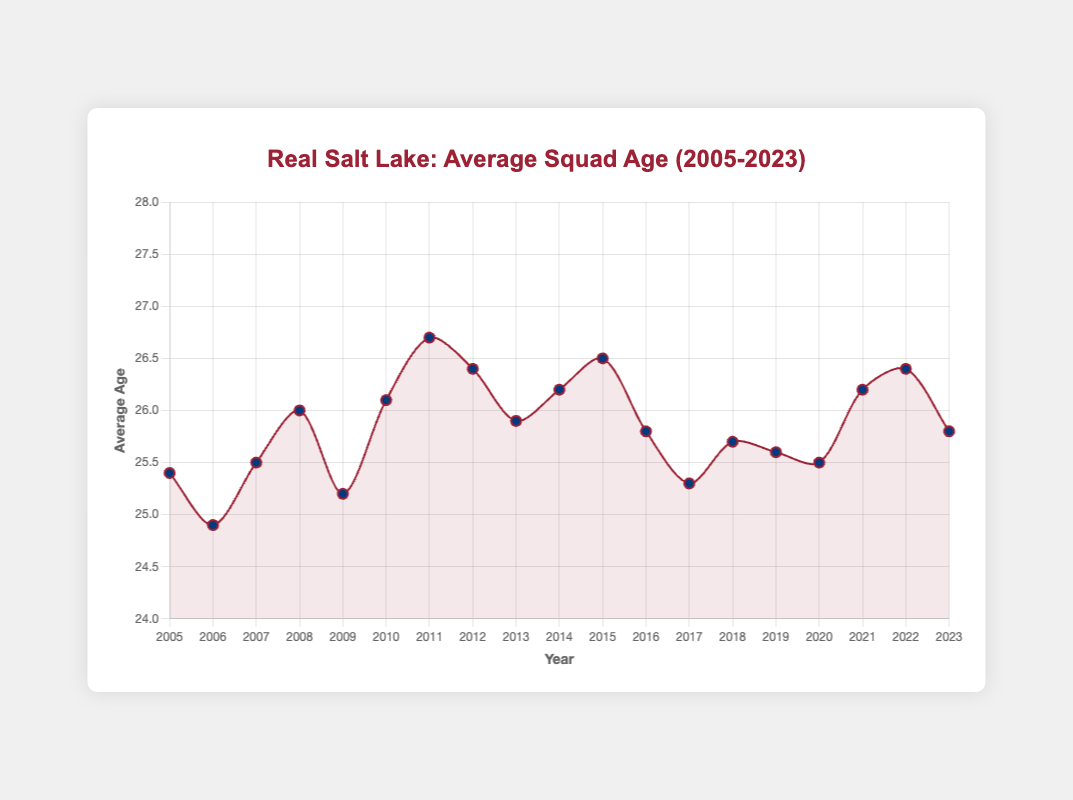What was the highest average age of the Real Salt Lake squad, and in which year did it occur? To find this, you look for the highest point on the curve and the corresponding year on the x-axis. The highest average age is 26.7 which occurred in 2011.
Answer: 26.7 in 2011 Which year had a lower average age, 2006 or 2023? Comparing the values for the years 2006 and 2023, 2006 had an average age of 24.9 while 2023 had an average age of 25.8. Hence, 2006 had a lower average age.
Answer: 2006 What is the average age difference between the years 2005 and 2018? Subtract the average age in 2005 (25.4) from the average age in 2018 (25.7). 25.7 - 25.4 = 0.3.
Answer: 0.3 Did the average age increase or decrease from 2010 to 2011? Visually inspect the curve between 2010 and 2011. The curve goes up from 26.1 to 26.7, indicating an increase.
Answer: Increase What is the general trend of the average squad age from 2005 to 2023? Examining the overall shape of the curve from 2005 to 2023, it appears there is a slight overall increase in average age, although there are fluctuations.
Answer: Slight increase How many years had an average age above 26? Count the years where the curve is above the 26 mark. The years are 2010, 2011, 2012, 2014, 2015, 2021, and 2022.
Answer: 7 years Which year marked the largest drop in average age from the previous year, and what was the drop? By comparing the year-to-year differences, the largest drop occurred from 2016 (25.8) to 2017 (25.3), resulting in a drop of 0.5.
Answer: 2017, drop of 0.5 Was the average age ever exactly 26.0? If so, in which year? Check the curve to see if it ever crosses the 26.0 line exactly. It happened in 2008.
Answer: 2008 